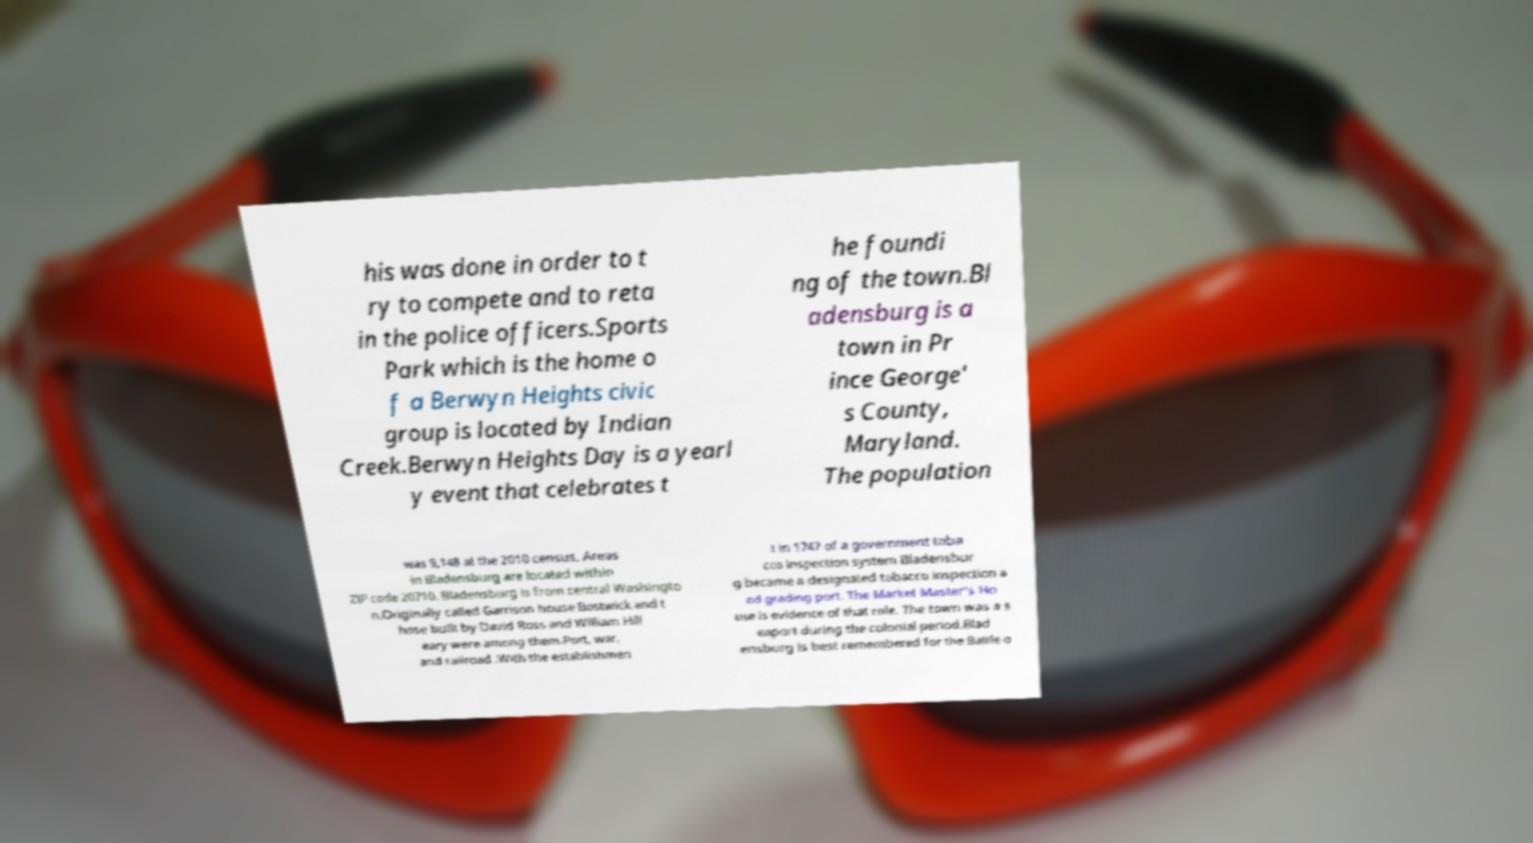Could you extract and type out the text from this image? his was done in order to t ry to compete and to reta in the police officers.Sports Park which is the home o f a Berwyn Heights civic group is located by Indian Creek.Berwyn Heights Day is a yearl y event that celebrates t he foundi ng of the town.Bl adensburg is a town in Pr ince George' s County, Maryland. The population was 9,148 at the 2010 census. Areas in Bladensburg are located within ZIP code 20710. Bladensburg is from central Washingto n.Originally called Garrison house Bostwick and t hose built by David Ross and William Hill eary were among them.Port, war, and railroad .With the establishmen t in 1747 of a government toba cco inspection system Bladensbur g became a designated tobacco inspection a nd grading port. The Market Master's Ho use is evidence of that role. The town was a s eaport during the colonial period.Blad ensburg is best remembered for the Battle o 